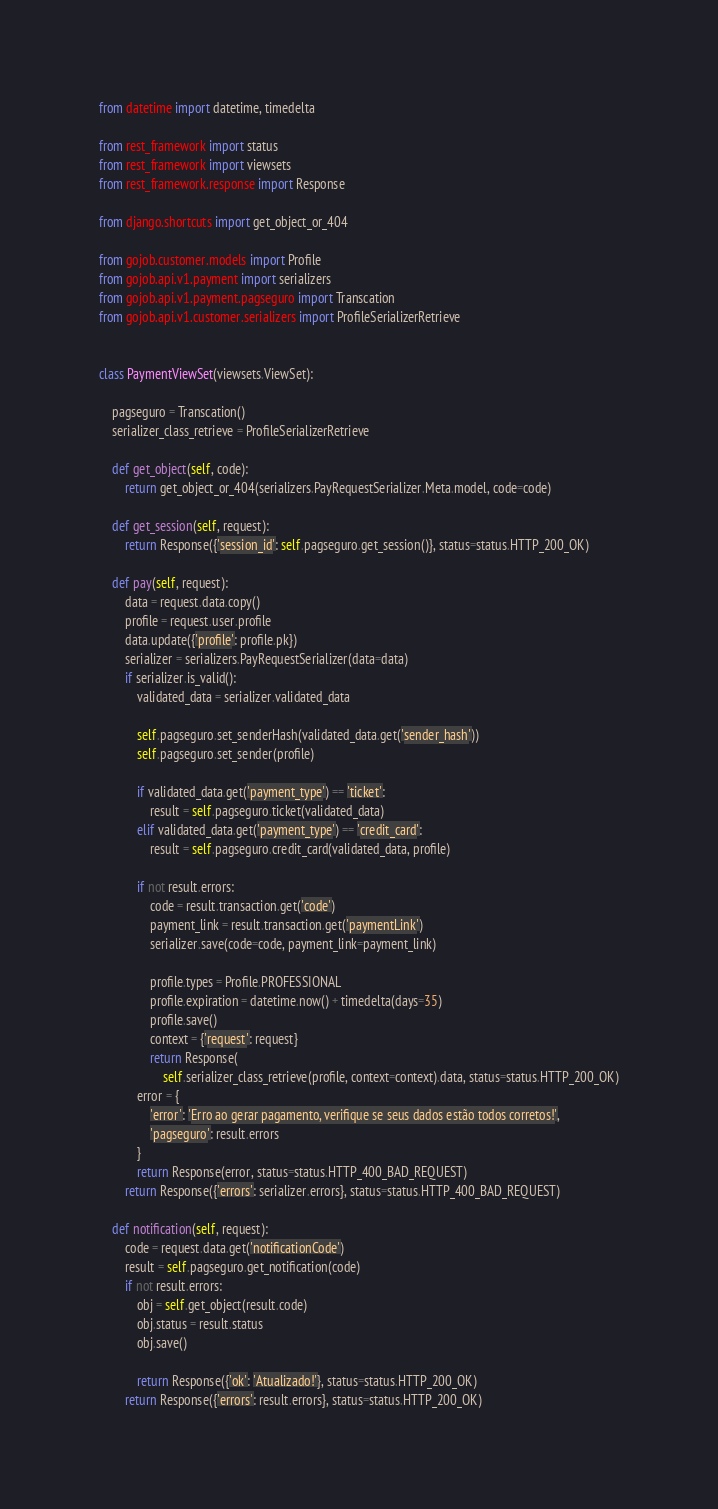Convert code to text. <code><loc_0><loc_0><loc_500><loc_500><_Python_>from datetime import datetime, timedelta

from rest_framework import status
from rest_framework import viewsets
from rest_framework.response import Response

from django.shortcuts import get_object_or_404

from gojob.customer.models import Profile
from gojob.api.v1.payment import serializers
from gojob.api.v1.payment.pagseguro import Transcation
from gojob.api.v1.customer.serializers import ProfileSerializerRetrieve


class PaymentViewSet(viewsets.ViewSet):

    pagseguro = Transcation()
    serializer_class_retrieve = ProfileSerializerRetrieve

    def get_object(self, code):
        return get_object_or_404(serializers.PayRequestSerializer.Meta.model, code=code)

    def get_session(self, request):
        return Response({'session_id': self.pagseguro.get_session()}, status=status.HTTP_200_OK)

    def pay(self, request):
        data = request.data.copy()
        profile = request.user.profile
        data.update({'profile': profile.pk})
        serializer = serializers.PayRequestSerializer(data=data)
        if serializer.is_valid():
            validated_data = serializer.validated_data

            self.pagseguro.set_senderHash(validated_data.get('sender_hash'))
            self.pagseguro.set_sender(profile)

            if validated_data.get('payment_type') == 'ticket':
                result = self.pagseguro.ticket(validated_data)
            elif validated_data.get('payment_type') == 'credit_card':
                result = self.pagseguro.credit_card(validated_data, profile)

            if not result.errors:
                code = result.transaction.get('code')
                payment_link = result.transaction.get('paymentLink')
                serializer.save(code=code, payment_link=payment_link)

                profile.types = Profile.PROFESSIONAL
                profile.expiration = datetime.now() + timedelta(days=35)
                profile.save()
                context = {'request': request}
                return Response(
                    self.serializer_class_retrieve(profile, context=context).data, status=status.HTTP_200_OK)
            error = {
                'error': 'Erro ao gerar pagamento, verifique se seus dados estão todos corretos!',
                'pagseguro': result.errors
            }
            return Response(error, status=status.HTTP_400_BAD_REQUEST)
        return Response({'errors': serializer.errors}, status=status.HTTP_400_BAD_REQUEST)

    def notification(self, request):
        code = request.data.get('notificationCode')
        result = self.pagseguro.get_notification(code)
        if not result.errors:
            obj = self.get_object(result.code)
            obj.status = result.status
            obj.save()

            return Response({'ok': 'Atualizado!'}, status=status.HTTP_200_OK)
        return Response({'errors': result.errors}, status=status.HTTP_200_OK)
</code> 